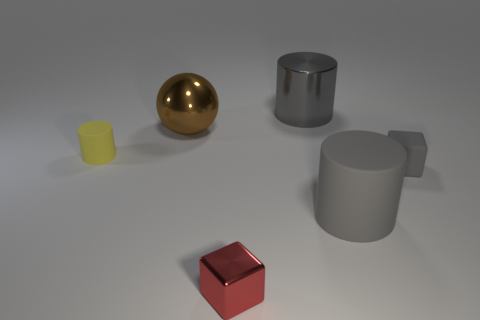Add 2 small gray things. How many objects exist? 8 Subtract all gray blocks. How many blocks are left? 1 Subtract all matte cylinders. How many cylinders are left? 1 Subtract 1 cylinders. How many cylinders are left? 2 Subtract all spheres. How many objects are left? 5 Subtract all blue spheres. Subtract all gray blocks. How many spheres are left? 1 Subtract all gray blocks. How many yellow cylinders are left? 1 Subtract all large green metallic cubes. Subtract all big gray objects. How many objects are left? 4 Add 5 metallic spheres. How many metallic spheres are left? 6 Add 6 cyan cubes. How many cyan cubes exist? 6 